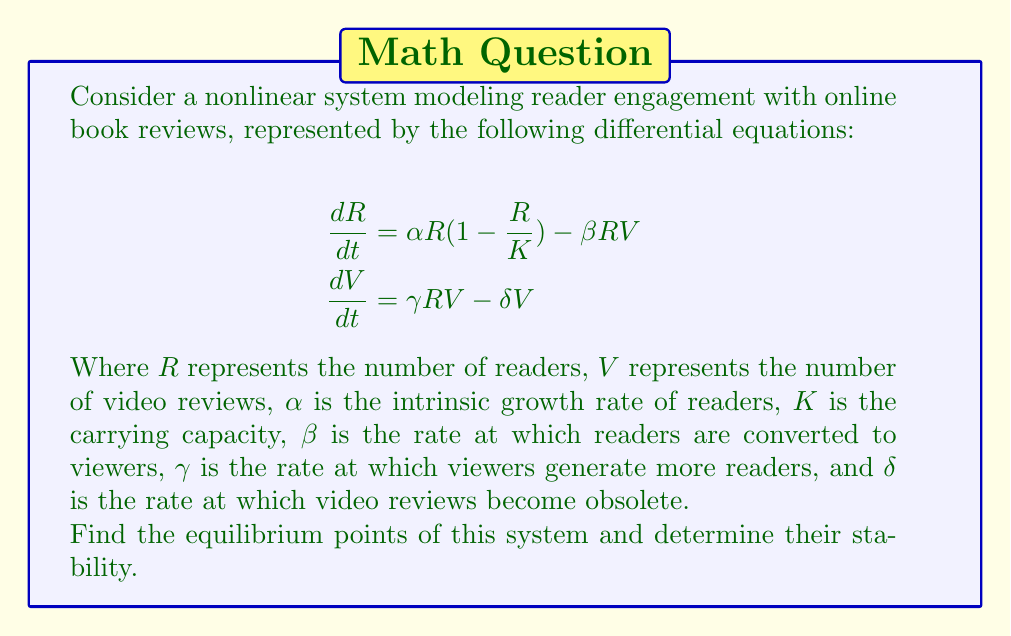Teach me how to tackle this problem. To solve this problem, we'll follow these steps:

1) Find the equilibrium points by setting both equations equal to zero and solving for R and V.

2) Linearize the system around each equilibrium point.

3) Evaluate the Jacobian matrix at each equilibrium point.

4) Determine the stability based on the eigenvalues of the Jacobian matrix.

Step 1: Finding equilibrium points

Set both equations to zero:

$$\begin{align}
0 &= \alpha R(1-\frac{R}{K}) - \beta RV \\
0 &= \gamma RV - \delta V
\end{align}$$

From the second equation, either $V=0$ or $R=\frac{\delta}{\gamma}$.

Case 1: If $V=0$, then from the first equation:
$0 = \alpha R(1-\frac{R}{K})$
So, $R=0$ or $R=K$

This gives us two equilibrium points: $(0,0)$ and $(K,0)$

Case 2: If $R=\frac{\delta}{\gamma}$, substitute this into the first equation:

$0 = \alpha \frac{\delta}{\gamma}(1-\frac{\delta}{\gamma K}) - \beta \frac{\delta}{\gamma}V$

Solving for V:

$V = \frac{\alpha}{\beta}(1-\frac{\delta}{\gamma K})$

This gives us the third equilibrium point: $(\frac{\delta}{\gamma}, \frac{\alpha}{\beta}(1-\frac{\delta}{\gamma K}))$

Step 2 & 3: Linearization and Jacobian matrix

The Jacobian matrix for this system is:

$$J = \begin{bmatrix}
\alpha(1-\frac{2R}{K})-\beta V & -\beta R \\
\gamma V & \gamma R - \delta
\end{bmatrix}$$

Step 4: Stability analysis

For $(0,0)$:
$$J_{(0,0)} = \begin{bmatrix}
\alpha & 0 \\
0 & -\delta
\end{bmatrix}$$
Eigenvalues: $\lambda_1 = \alpha$, $\lambda_2 = -\delta$
This is a saddle point (unstable) since $\alpha > 0$ and $\delta > 0$.

For $(K,0)$:
$$J_{(K,0)} = \begin{bmatrix}
-\alpha & -\beta K \\
0 & \gamma K - \delta
\end{bmatrix}$$
Eigenvalues: $\lambda_1 = -\alpha$, $\lambda_2 = \gamma K - \delta$
This is stable if $\gamma K < \delta$, unstable otherwise.

For $(\frac{\delta}{\gamma}, \frac{\alpha}{\beta}(1-\frac{\delta}{\gamma K}))$:
The stability of this point depends on the specific values of the parameters and requires more complex analysis.
Answer: Three equilibrium points: $(0,0)$ (unstable), $(K,0)$ (conditionally stable), $(\frac{\delta}{\gamma}, \frac{\alpha}{\beta}(1-\frac{\delta}{\gamma K}))$ (stability depends on parameter values). 